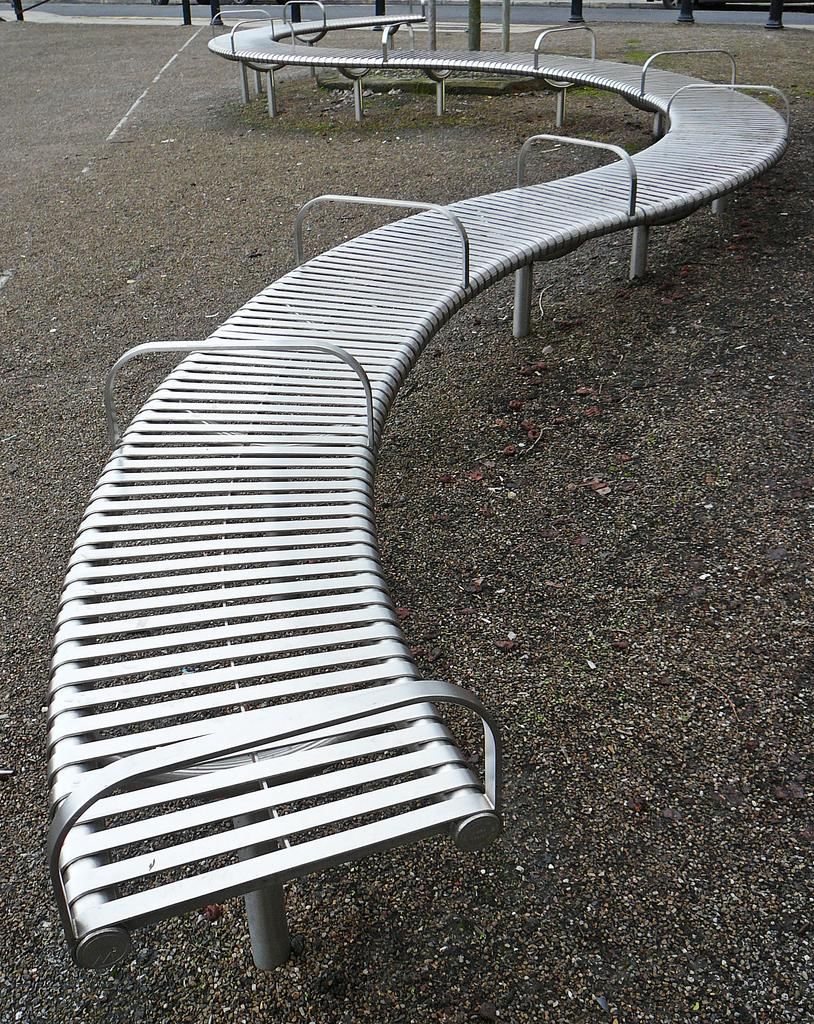What is the main feature in the center of the image? There is a boardwalk in the center of the image. How is the boardwalk positioned in relation to the ground? The boardwalk is on the ground. What can be seen in the background of the image? There are pillars and water visible in the background of the image. What is the tendency of the lumber to float in the water in the image? There is no lumber present in the image, so it is not possible to determine its tendency to float in the water. 